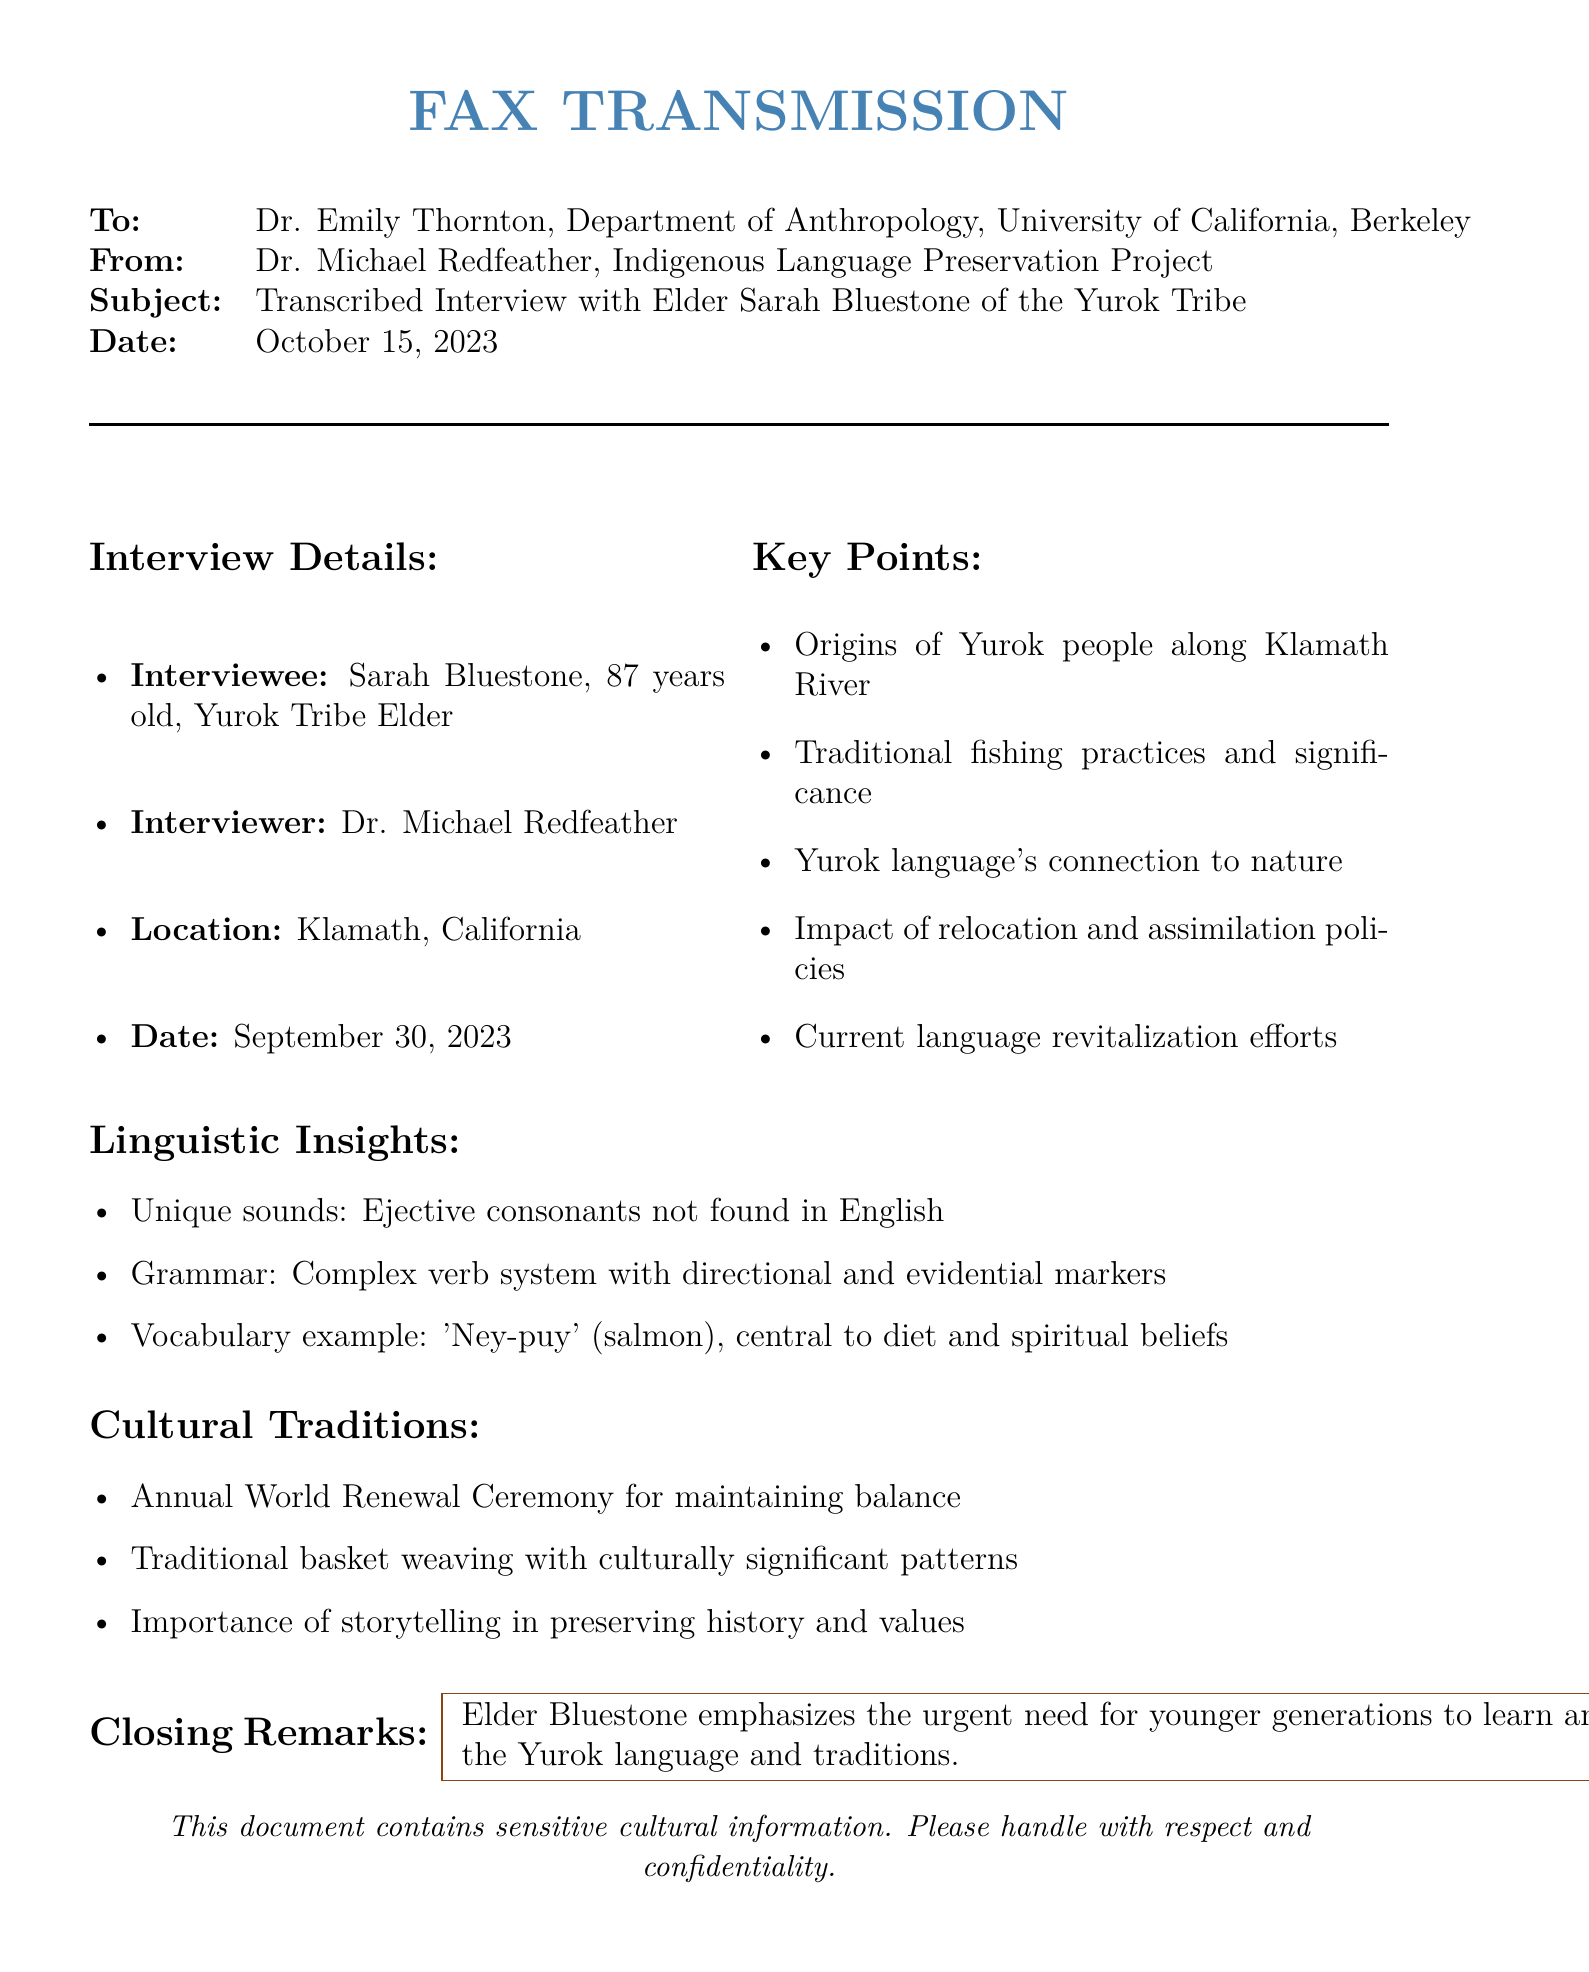What is the name of the interviewee? The interviewee's name is given in the document as Sarah Bluestone.
Answer: Sarah Bluestone What tribe does Elder Sarah Bluestone belong to? The document states that she is from the Yurok Tribe.
Answer: Yurok Tribe What is the date of the interview? The exact date of the interview is listed as September 30, 2023.
Answer: September 30, 2023 What is the primary food source mentioned in the document? The vocabulary example highlights 'Ney-puy' as the central dietary component.
Answer: Salmon What is the complex grammatical feature of the Yurok language? The document describes a complex verb system with markers relevant to direction and evidence.
Answer: Directional and evidential markers Why is storytelling important according to Elder Bluestone? The document states that storytelling is important for preserving history and values.
Answer: Preserving history and values How old is Elder Sarah Bluestone? The document specifies her age, mentioning that she is 87 years old.
Answer: 87 years old What ceremony is mentioned for maintaining balance? The document explicitly mentions the Annual World Renewal Ceremony as the key event.
Answer: Annual World Renewal Ceremony Who conducted the interview? The interviewer's name is given as Dr. Michael Redfeather in the document.
Answer: Dr. Michael Redfeather 